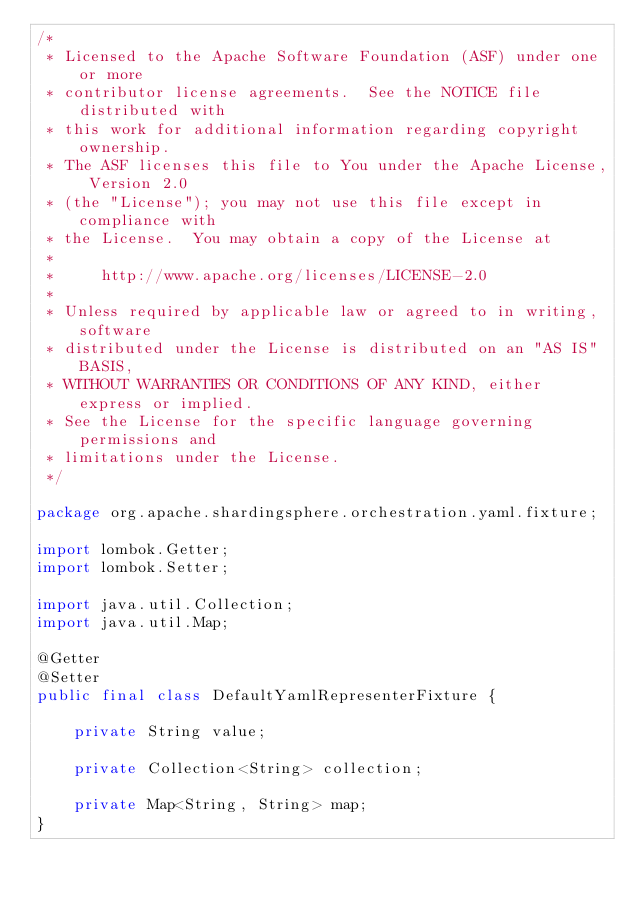<code> <loc_0><loc_0><loc_500><loc_500><_Java_>/*
 * Licensed to the Apache Software Foundation (ASF) under one or more
 * contributor license agreements.  See the NOTICE file distributed with
 * this work for additional information regarding copyright ownership.
 * The ASF licenses this file to You under the Apache License, Version 2.0
 * (the "License"); you may not use this file except in compliance with
 * the License.  You may obtain a copy of the License at
 *
 *     http://www.apache.org/licenses/LICENSE-2.0
 *
 * Unless required by applicable law or agreed to in writing, software
 * distributed under the License is distributed on an "AS IS" BASIS,
 * WITHOUT WARRANTIES OR CONDITIONS OF ANY KIND, either express or implied.
 * See the License for the specific language governing permissions and
 * limitations under the License.
 */

package org.apache.shardingsphere.orchestration.yaml.fixture;

import lombok.Getter;
import lombok.Setter;

import java.util.Collection;
import java.util.Map;

@Getter
@Setter
public final class DefaultYamlRepresenterFixture {
    
    private String value;
    
    private Collection<String> collection;
    
    private Map<String, String> map;
}
</code> 